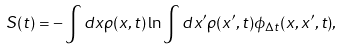<formula> <loc_0><loc_0><loc_500><loc_500>S ( t ) = - \int d x \rho ( x , t ) \ln \int d x ^ { \prime } \rho ( x ^ { \prime } , t ) \phi _ { \Delta t } ( x , x ^ { \prime } , t ) ,</formula> 